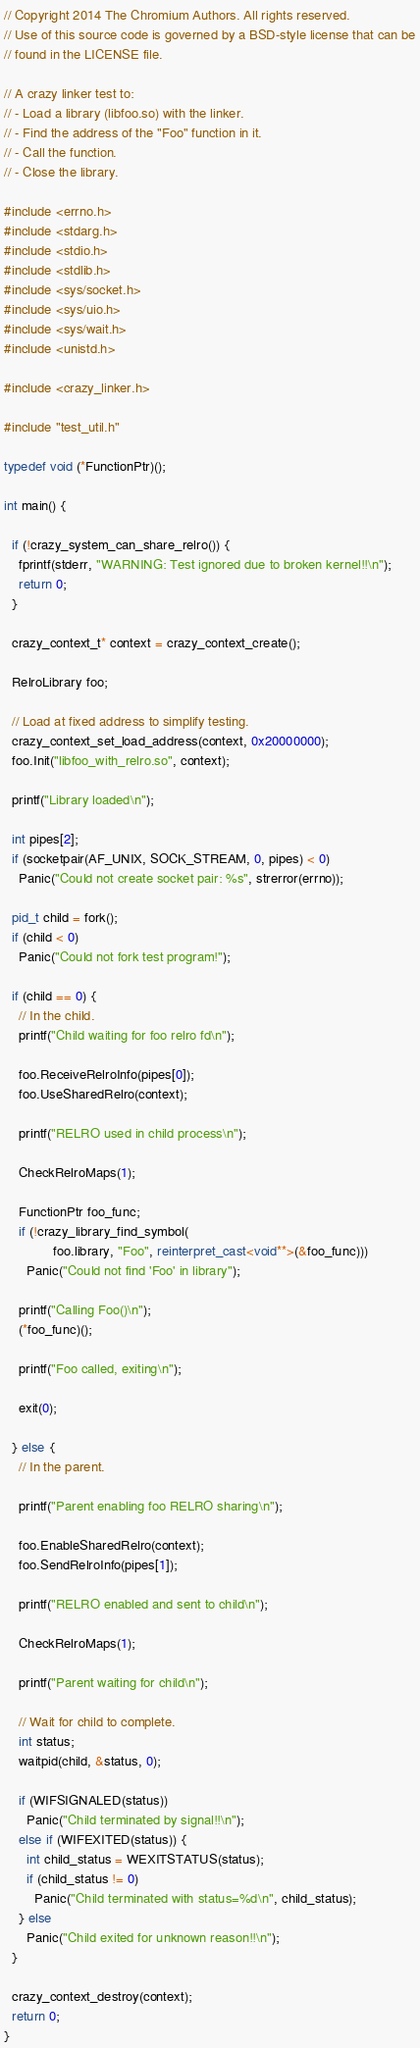<code> <loc_0><loc_0><loc_500><loc_500><_C++_>// Copyright 2014 The Chromium Authors. All rights reserved.
// Use of this source code is governed by a BSD-style license that can be
// found in the LICENSE file.

// A crazy linker test to:
// - Load a library (libfoo.so) with the linker.
// - Find the address of the "Foo" function in it.
// - Call the function.
// - Close the library.

#include <errno.h>
#include <stdarg.h>
#include <stdio.h>
#include <stdlib.h>
#include <sys/socket.h>
#include <sys/uio.h>
#include <sys/wait.h>
#include <unistd.h>

#include <crazy_linker.h>

#include "test_util.h"

typedef void (*FunctionPtr)();

int main() {

  if (!crazy_system_can_share_relro()) {
    fprintf(stderr, "WARNING: Test ignored due to broken kernel!!\n");
    return 0;
  }

  crazy_context_t* context = crazy_context_create();

  RelroLibrary foo;

  // Load at fixed address to simplify testing.
  crazy_context_set_load_address(context, 0x20000000);
  foo.Init("libfoo_with_relro.so", context);

  printf("Library loaded\n");

  int pipes[2];
  if (socketpair(AF_UNIX, SOCK_STREAM, 0, pipes) < 0)
    Panic("Could not create socket pair: %s", strerror(errno));

  pid_t child = fork();
  if (child < 0)
    Panic("Could not fork test program!");

  if (child == 0) {
    // In the child.
    printf("Child waiting for foo relro fd\n");

    foo.ReceiveRelroInfo(pipes[0]);
    foo.UseSharedRelro(context);

    printf("RELRO used in child process\n");

    CheckRelroMaps(1);

    FunctionPtr foo_func;
    if (!crazy_library_find_symbol(
             foo.library, "Foo", reinterpret_cast<void**>(&foo_func)))
      Panic("Could not find 'Foo' in library");

    printf("Calling Foo()\n");
    (*foo_func)();

    printf("Foo called, exiting\n");

    exit(0);

  } else {
    // In the parent.

    printf("Parent enabling foo RELRO sharing\n");

    foo.EnableSharedRelro(context);
    foo.SendRelroInfo(pipes[1]);

    printf("RELRO enabled and sent to child\n");

    CheckRelroMaps(1);

    printf("Parent waiting for child\n");

    // Wait for child to complete.
    int status;
    waitpid(child, &status, 0);

    if (WIFSIGNALED(status))
      Panic("Child terminated by signal!!\n");
    else if (WIFEXITED(status)) {
      int child_status = WEXITSTATUS(status);
      if (child_status != 0)
        Panic("Child terminated with status=%d\n", child_status);
    } else
      Panic("Child exited for unknown reason!!\n");
  }

  crazy_context_destroy(context);
  return 0;
}
</code> 